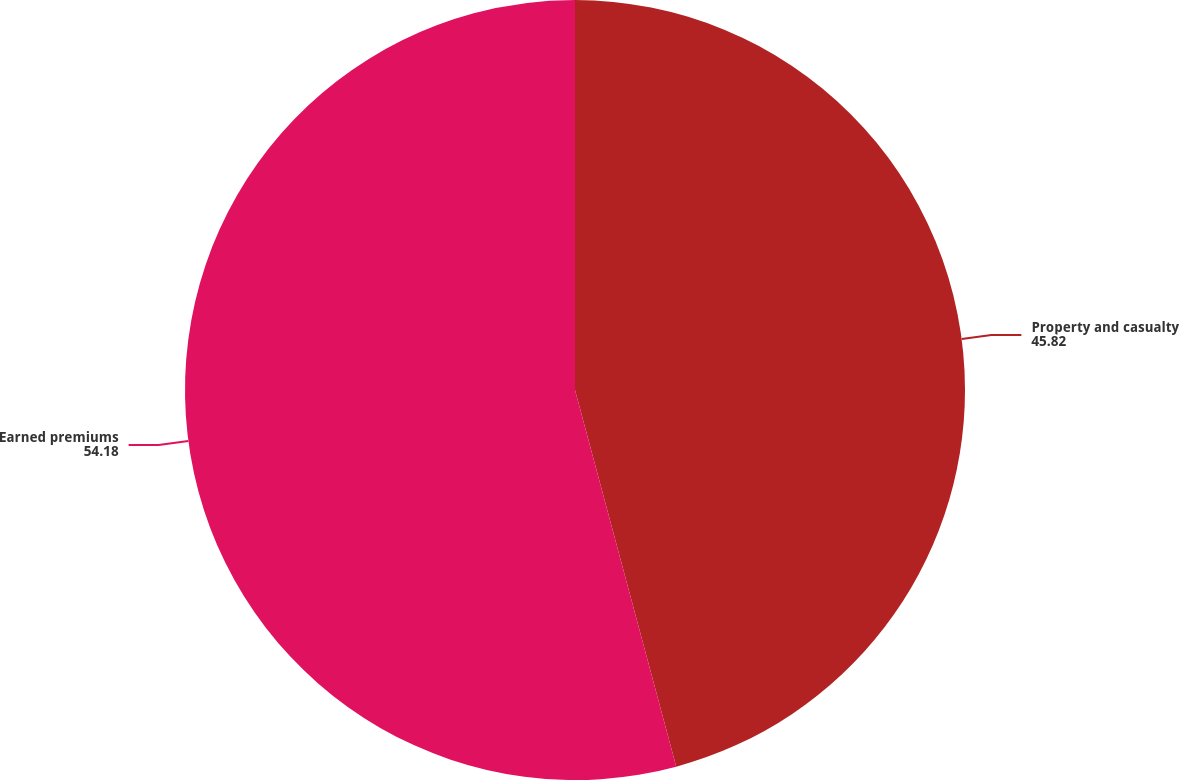Convert chart. <chart><loc_0><loc_0><loc_500><loc_500><pie_chart><fcel>Property and casualty<fcel>Earned premiums<nl><fcel>45.82%<fcel>54.18%<nl></chart> 